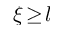<formula> <loc_0><loc_0><loc_500><loc_500>\xi \, \geq \, l</formula> 